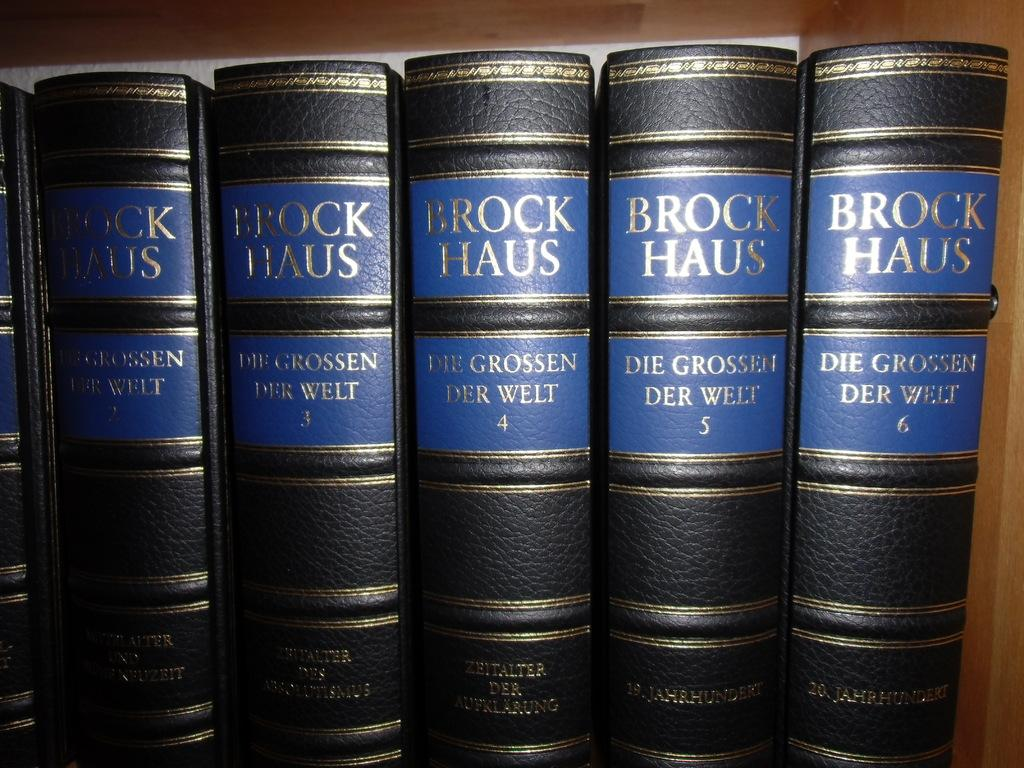<image>
Offer a succinct explanation of the picture presented. A series of black leather bound books with Brock Haus written on them. 